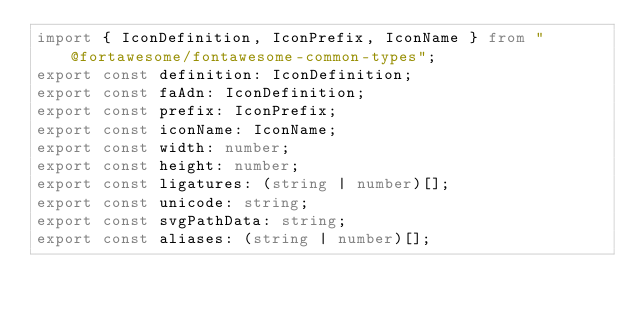<code> <loc_0><loc_0><loc_500><loc_500><_TypeScript_>import { IconDefinition, IconPrefix, IconName } from "@fortawesome/fontawesome-common-types";
export const definition: IconDefinition;
export const faAdn: IconDefinition;
export const prefix: IconPrefix;
export const iconName: IconName;
export const width: number;
export const height: number;
export const ligatures: (string | number)[];
export const unicode: string;
export const svgPathData: string;
export const aliases: (string | number)[];</code> 